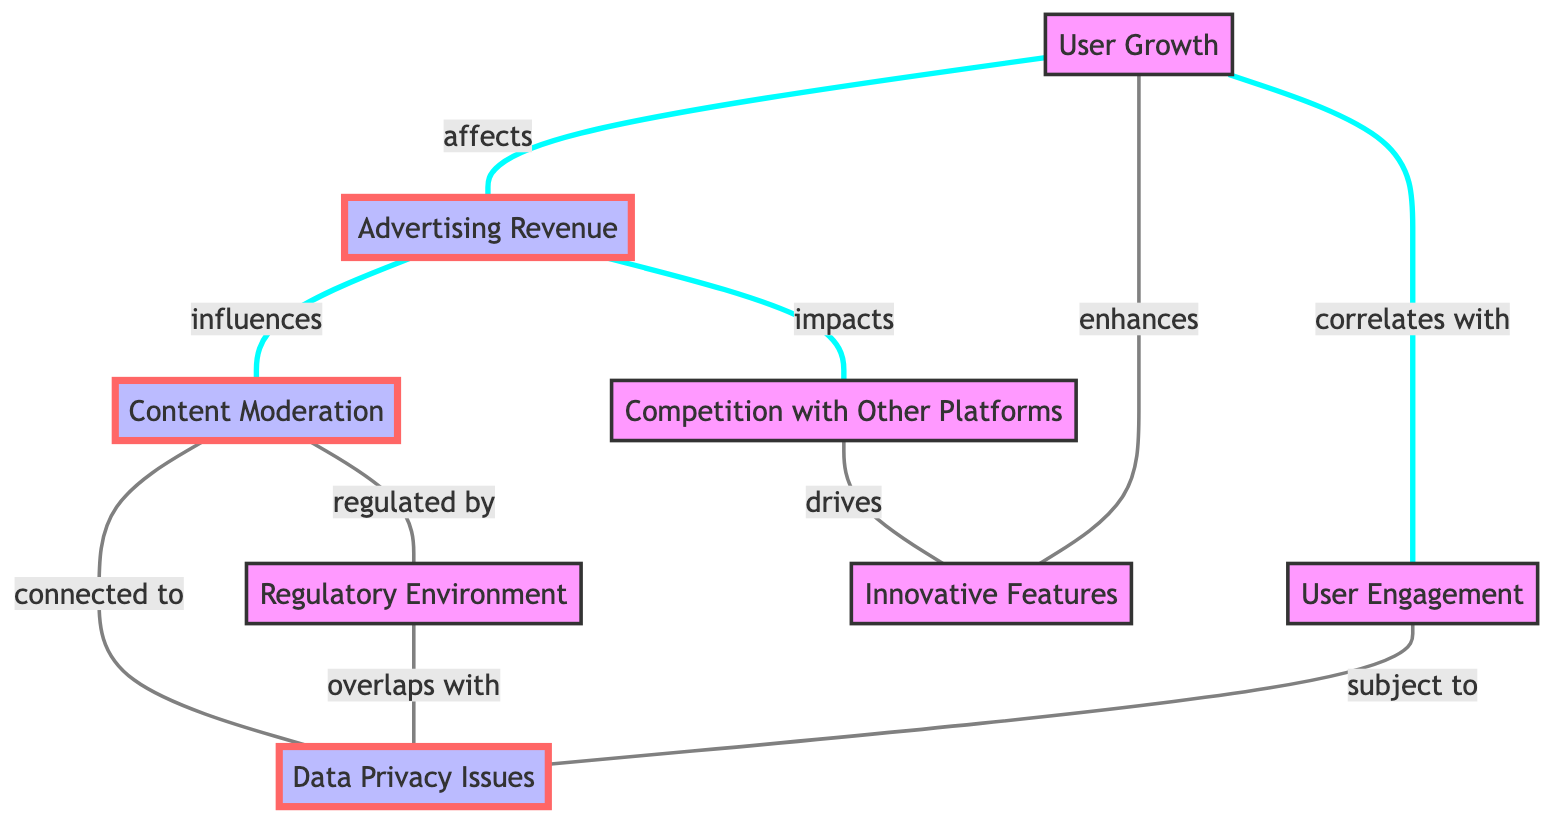What are the total number of nodes in the diagram? The diagram contains a list of nodes including User Growth, Advertising Revenue, Content Moderation, Competition with Other Platforms, Innovative Features, Regulatory Environment, User Engagement, and Data Privacy Issues. Counting these, we find there are eight nodes.
Answer: 8 What does User Growth correlate with? The diagram shows an edge labeled "correlates with" connecting User Growth to User Engagement. Therefore, User Growth correlates with User Engagement.
Answer: User Engagement What is influenced by Advertising Revenue? According to the diagram, there are two edges originating from Advertising Revenue: one labeled "influences" connecting to Content Moderation and another labeled "impacts" connecting to Competition with Other Platforms. Hence, Advertising Revenue influences Content Moderation.
Answer: Content Moderation Which node drives Innovative Features? The diagram indicates an edge labeled "drives" connecting the node Competition with Other Platforms to Innovative Features. It implies that the node Competition with Other Platforms is responsible for driving Innovative Features.
Answer: Competition with Other Platforms How many edges are connected to Content Moderation? Examining the diagram, we can see that Content Moderation has edges connecting to two nodes: Advertising Revenue (influences) and Regulatory Environment (regulated by), and also connects to Data Privacy Issues (connected to). Thus, there are three edges connected to Content Moderation.
Answer: 3 Which nodes are subject to Data Privacy Issues? Looking at the diagram, Data Privacy Issues connects with Content Moderation (connected to) and User Engagement (subject to). Therefore, User Engagement is subject to Data Privacy Issues.
Answer: User Engagement What overlaps with Regulatory Environment? From the diagram, the edge labeled "overlaps with" from Regulatory Environment connects to the node Data Privacy Issues. So, Regulatory Environment overlaps with Data Privacy Issues.
Answer: Data Privacy Issues How does Innovative Features affect User Growth? The diagram shows an edge labeled "enhances" coming from Innovative Features to User Growth. This means that Innovative Features has a positive effect on User Growth, enhancing it.
Answer: enhances What is the relationship between User Engagement and Data Privacy Issues? The diagram shows an edge labeled "subject to" going from User Engagement to Data Privacy Issues. This indicates that User Engagement is influenced or constrained by Data Privacy Issues.
Answer: subject to What node is most directly affected by Advertising Revenue? Advertising Revenue directly affects Content Moderation based on the edge labeled "influences" in the diagram. Thus, the node most directly affected by Advertising Revenue is Content Moderation.
Answer: Content Moderation 